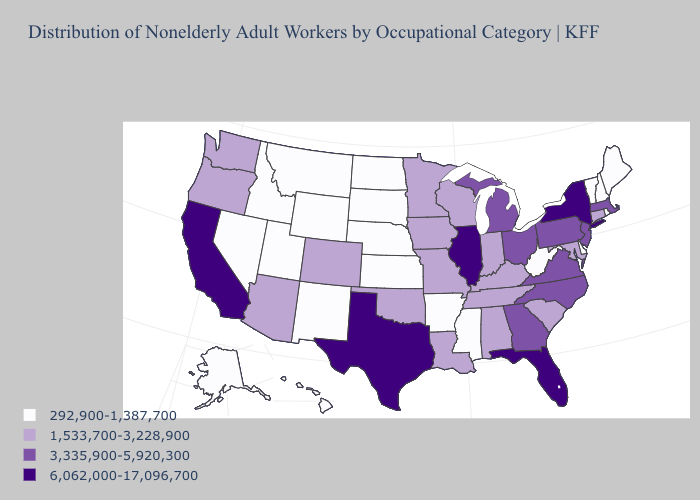Name the states that have a value in the range 292,900-1,387,700?
Write a very short answer. Alaska, Arkansas, Delaware, Hawaii, Idaho, Kansas, Maine, Mississippi, Montana, Nebraska, Nevada, New Hampshire, New Mexico, North Dakota, Rhode Island, South Dakota, Utah, Vermont, West Virginia, Wyoming. What is the lowest value in the USA?
Write a very short answer. 292,900-1,387,700. What is the lowest value in the West?
Answer briefly. 292,900-1,387,700. What is the lowest value in states that border New Jersey?
Answer briefly. 292,900-1,387,700. Which states have the highest value in the USA?
Quick response, please. California, Florida, Illinois, New York, Texas. What is the value of Iowa?
Be succinct. 1,533,700-3,228,900. Which states have the lowest value in the South?
Be succinct. Arkansas, Delaware, Mississippi, West Virginia. Does Texas have the highest value in the South?
Be succinct. Yes. What is the value of Wyoming?
Keep it brief. 292,900-1,387,700. What is the value of Texas?
Concise answer only. 6,062,000-17,096,700. Does Minnesota have the lowest value in the USA?
Give a very brief answer. No. What is the value of Hawaii?
Short answer required. 292,900-1,387,700. Name the states that have a value in the range 6,062,000-17,096,700?
Quick response, please. California, Florida, Illinois, New York, Texas. Which states have the lowest value in the Northeast?
Write a very short answer. Maine, New Hampshire, Rhode Island, Vermont. What is the value of Arkansas?
Quick response, please. 292,900-1,387,700. 